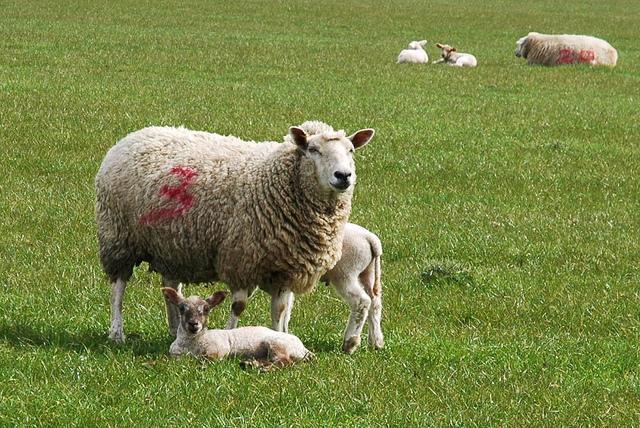How many sheep are in the picture?
Give a very brief answer. 6. How many sheep are babies?
Give a very brief answer. 4. How many baby sheep are in the picture?
Give a very brief answer. 4. How many sheep are there?
Give a very brief answer. 4. 